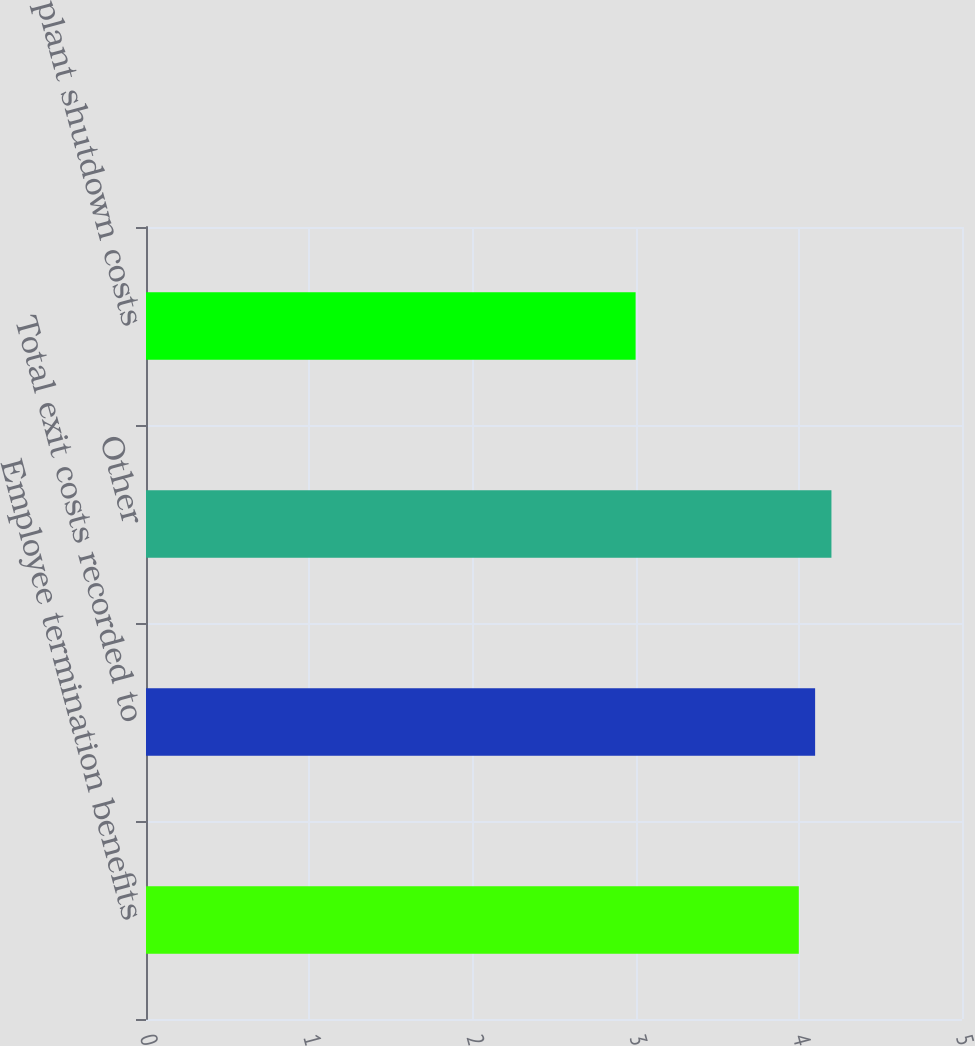Convert chart to OTSL. <chart><loc_0><loc_0><loc_500><loc_500><bar_chart><fcel>Employee termination benefits<fcel>Total exit costs recorded to<fcel>Other<fcel>Total plant shutdown costs<nl><fcel>4<fcel>4.1<fcel>4.2<fcel>3<nl></chart> 